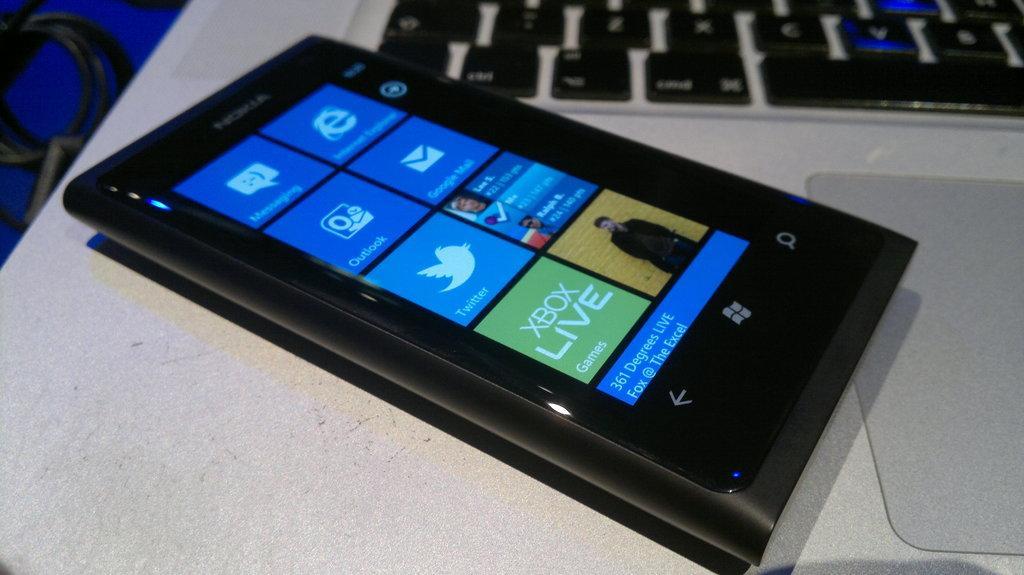Describe this image in one or two sentences. As we can see in the image there is a table. On table there is mobile phone, mat and keyboard. 